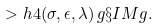Convert formula to latex. <formula><loc_0><loc_0><loc_500><loc_500>> h { 4 } ( \sigma , \epsilon , \lambda ) \, g \S I M g .</formula> 